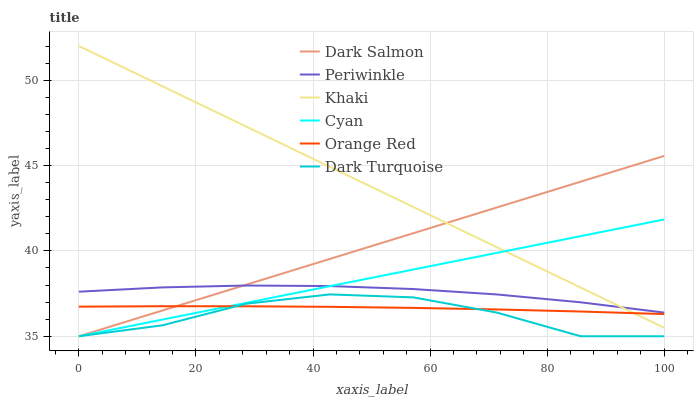Does Dark Turquoise have the minimum area under the curve?
Answer yes or no. Yes. Does Khaki have the maximum area under the curve?
Answer yes or no. Yes. Does Dark Salmon have the minimum area under the curve?
Answer yes or no. No. Does Dark Salmon have the maximum area under the curve?
Answer yes or no. No. Is Khaki the smoothest?
Answer yes or no. Yes. Is Dark Turquoise the roughest?
Answer yes or no. Yes. Is Dark Salmon the smoothest?
Answer yes or no. No. Is Dark Salmon the roughest?
Answer yes or no. No. Does Dark Turquoise have the lowest value?
Answer yes or no. Yes. Does Periwinkle have the lowest value?
Answer yes or no. No. Does Khaki have the highest value?
Answer yes or no. Yes. Does Dark Turquoise have the highest value?
Answer yes or no. No. Is Dark Turquoise less than Periwinkle?
Answer yes or no. Yes. Is Periwinkle greater than Orange Red?
Answer yes or no. Yes. Does Periwinkle intersect Cyan?
Answer yes or no. Yes. Is Periwinkle less than Cyan?
Answer yes or no. No. Is Periwinkle greater than Cyan?
Answer yes or no. No. Does Dark Turquoise intersect Periwinkle?
Answer yes or no. No. 